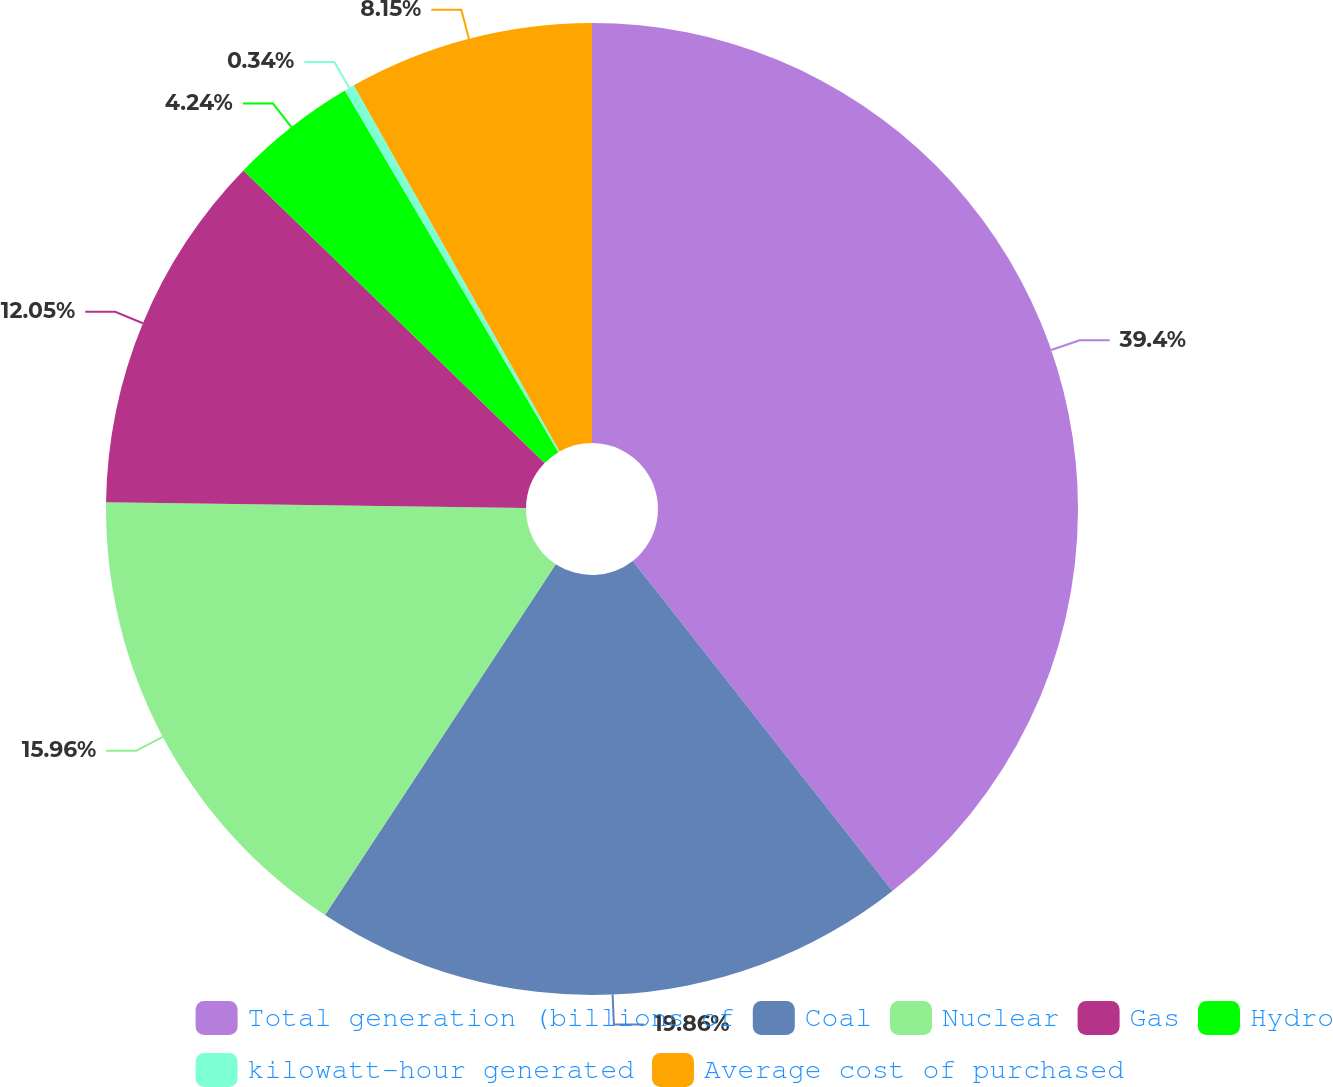Convert chart. <chart><loc_0><loc_0><loc_500><loc_500><pie_chart><fcel>Total generation (billions of<fcel>Coal<fcel>Nuclear<fcel>Gas<fcel>Hydro<fcel>kilowatt-hour generated<fcel>Average cost of purchased<nl><fcel>39.39%<fcel>19.86%<fcel>15.96%<fcel>12.05%<fcel>4.24%<fcel>0.34%<fcel>8.15%<nl></chart> 